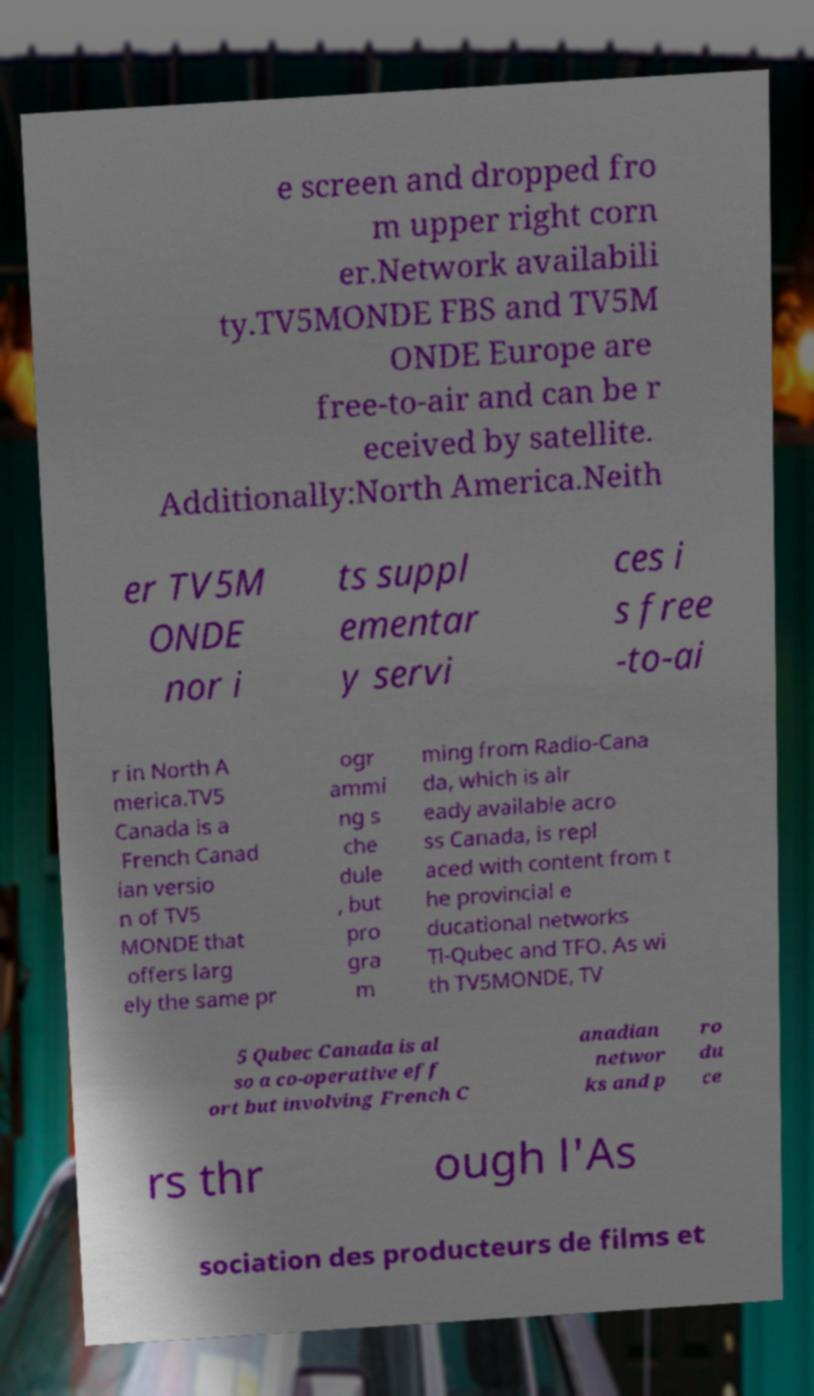There's text embedded in this image that I need extracted. Can you transcribe it verbatim? e screen and dropped fro m upper right corn er.Network availabili ty.TV5MONDE FBS and TV5M ONDE Europe are free-to-air and can be r eceived by satellite. Additionally:North America.Neith er TV5M ONDE nor i ts suppl ementar y servi ces i s free -to-ai r in North A merica.TV5 Canada is a French Canad ian versio n of TV5 MONDE that offers larg ely the same pr ogr ammi ng s che dule , but pro gra m ming from Radio-Cana da, which is alr eady available acro ss Canada, is repl aced with content from t he provincial e ducational networks Tl-Qubec and TFO. As wi th TV5MONDE, TV 5 Qubec Canada is al so a co-operative eff ort but involving French C anadian networ ks and p ro du ce rs thr ough l'As sociation des producteurs de films et 